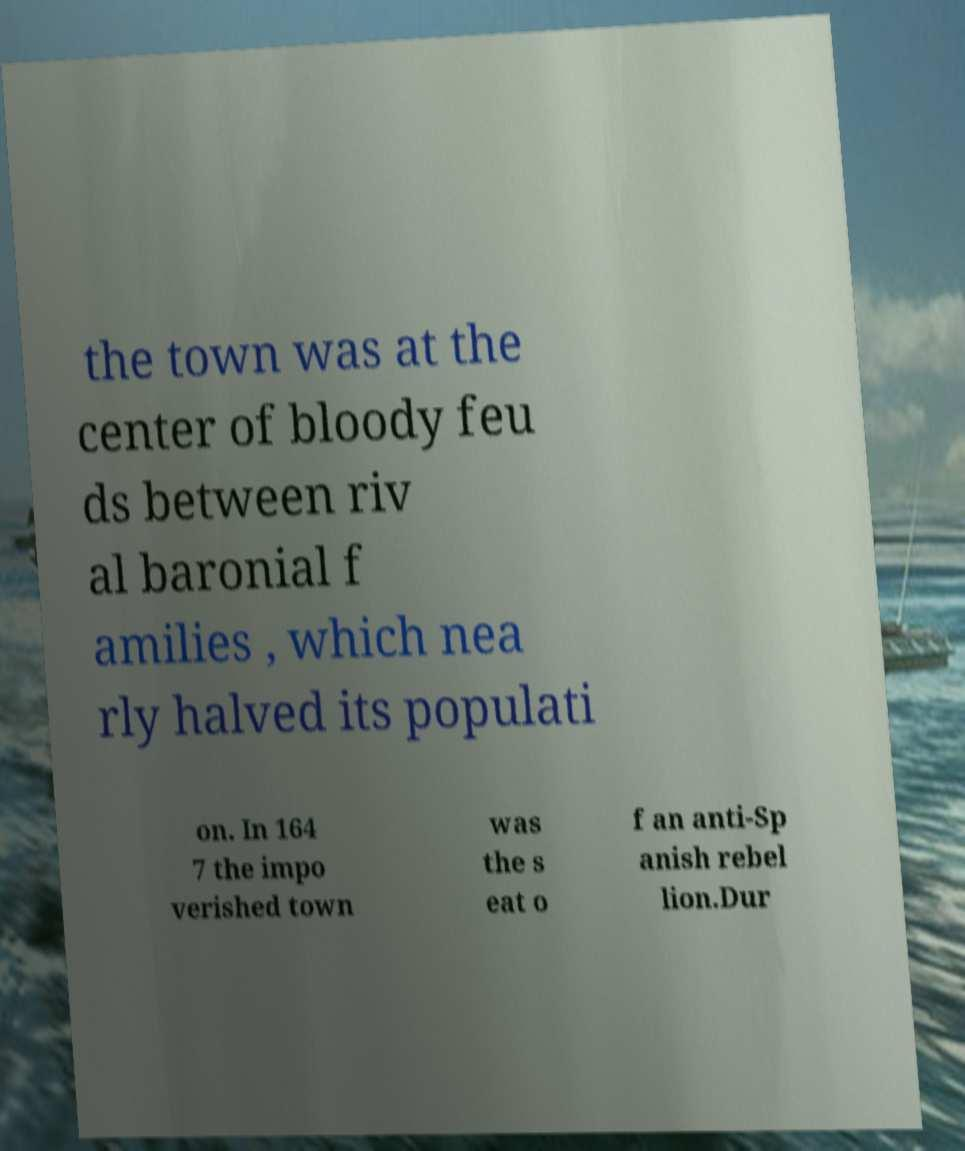Can you read and provide the text displayed in the image?This photo seems to have some interesting text. Can you extract and type it out for me? the town was at the center of bloody feu ds between riv al baronial f amilies , which nea rly halved its populati on. In 164 7 the impo verished town was the s eat o f an anti-Sp anish rebel lion.Dur 